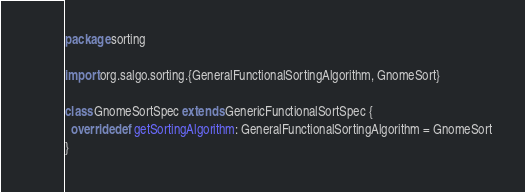Convert code to text. <code><loc_0><loc_0><loc_500><loc_500><_Scala_>package sorting

import org.salgo.sorting.{GeneralFunctionalSortingAlgorithm, GnomeSort}

class GnomeSortSpec extends GenericFunctionalSortSpec {
  override def getSortingAlgorithm: GeneralFunctionalSortingAlgorithm = GnomeSort
}
</code> 